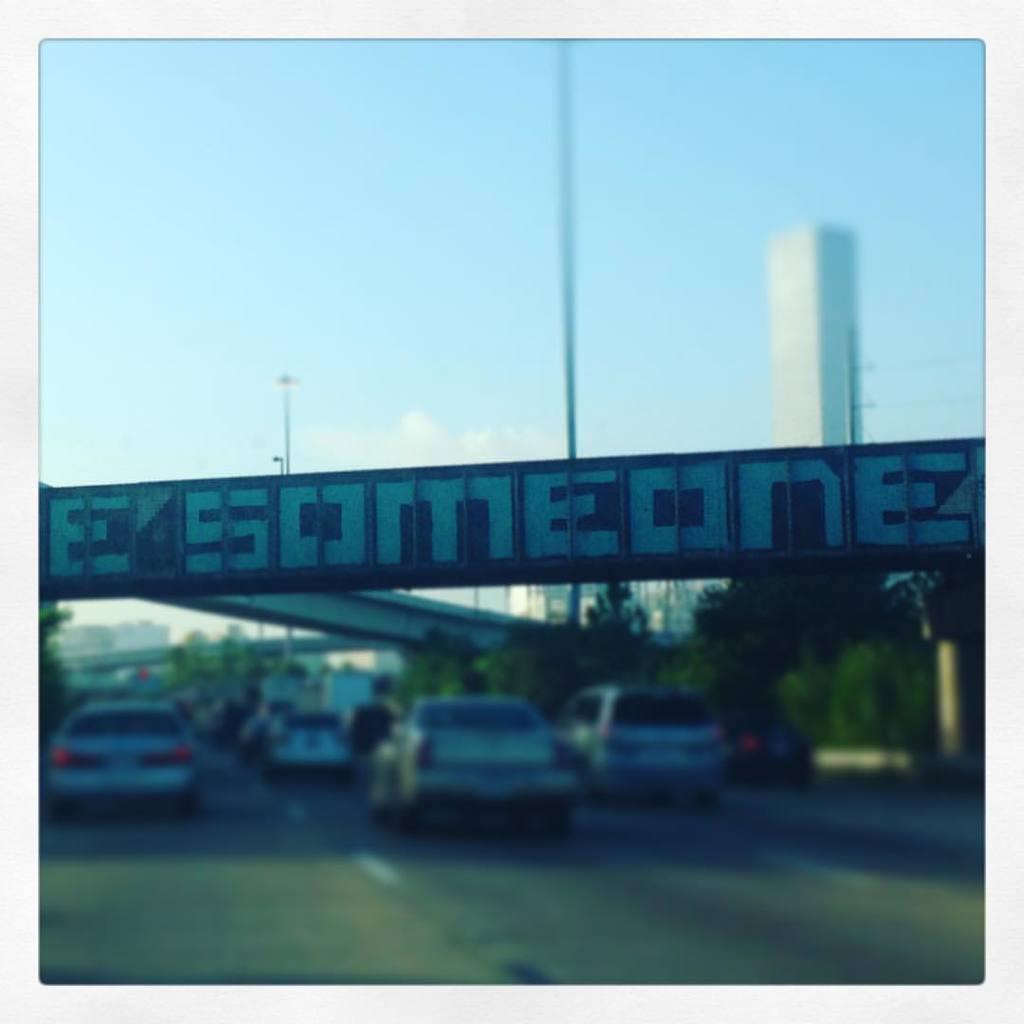In one or two sentences, can you explain what this image depicts? This is an outside view. At the bottom there are few cars on the road and also there are some trees and a bridge. In the middle of the image there is a board. At the top of the image I see the sky. 